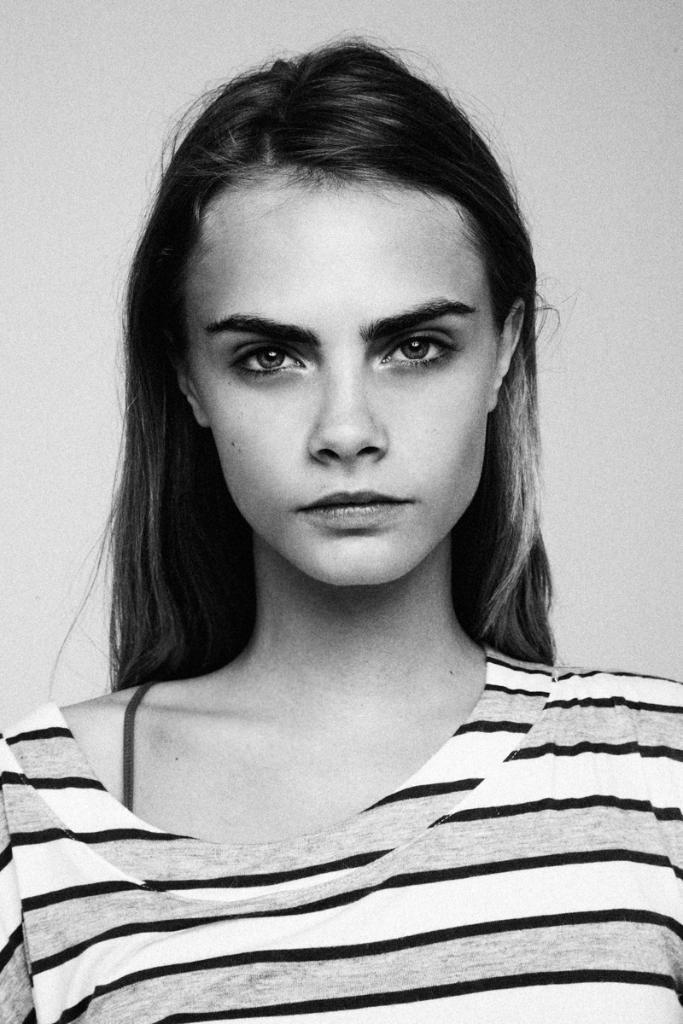How would you summarize this image in a sentence or two? In this image I can see a woman and I can see this image is black and white in colour. 